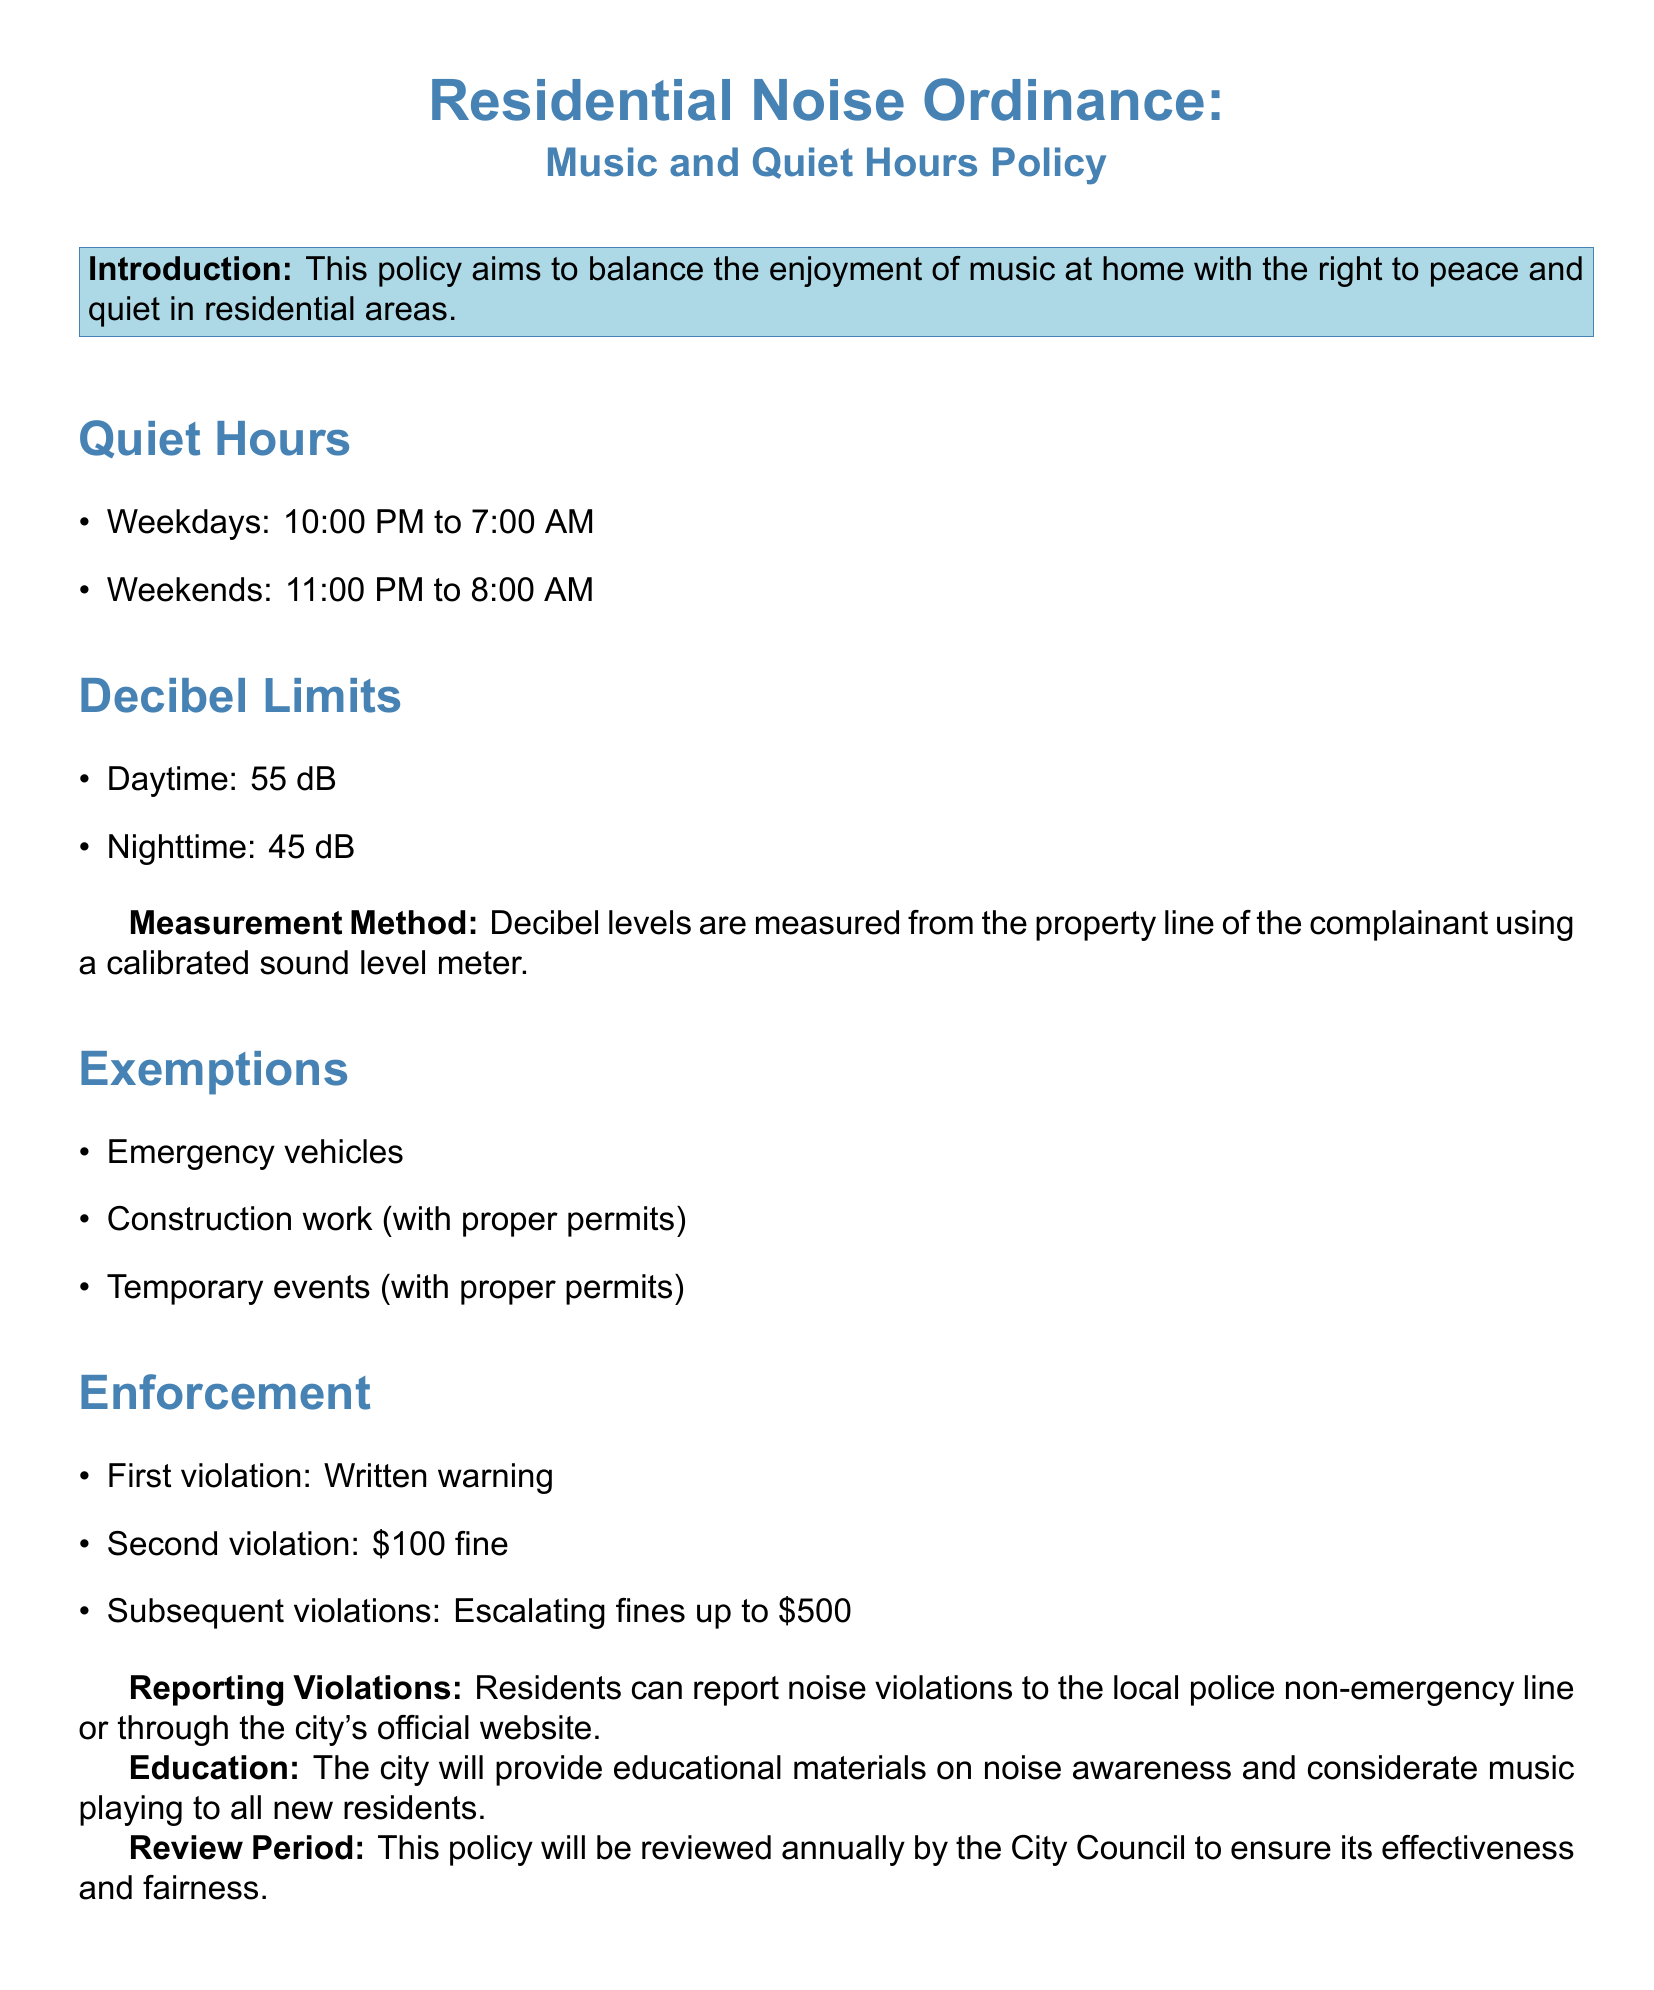What are the quiet hours on weekdays? The quiet hours on weekdays are specified in the document as 10:00 PM to 7:00 AM.
Answer: 10:00 PM to 7:00 AM What is the decibel limit during daytime? The document states the daytime decibel limit clearly as 55 dB.
Answer: 55 dB What are the quiet hours on weekends? The quiet hours on weekends are outlined as 11:00 PM to 8:00 AM.
Answer: 11:00 PM to 8:00 AM What is the penalty for a second violation? The document specifies that the penalty for a second violation is a $100 fine.
Answer: $100 fine How is noise measured according to the policy? The document explains that noise levels are measured using a calibrated sound level meter from the complainant's property line.
Answer: Calibrated sound level meter What exemptions are listed in the policy? The document lists three exemptions: emergency vehicles, construction work, and temporary events (with proper permits).
Answer: Emergency vehicles, construction work, temporary events What happens after the first violation? According to the policy, the consequence after the first violation is a written warning.
Answer: Written warning When will the policy be reviewed? The document states that this policy will be reviewed annually by the City Council.
Answer: Annually What is the purpose of this policy? The purpose of the policy is to balance the enjoyment of music at home with the right to peace and quiet in residential areas.
Answer: Balance enjoyment and peace 